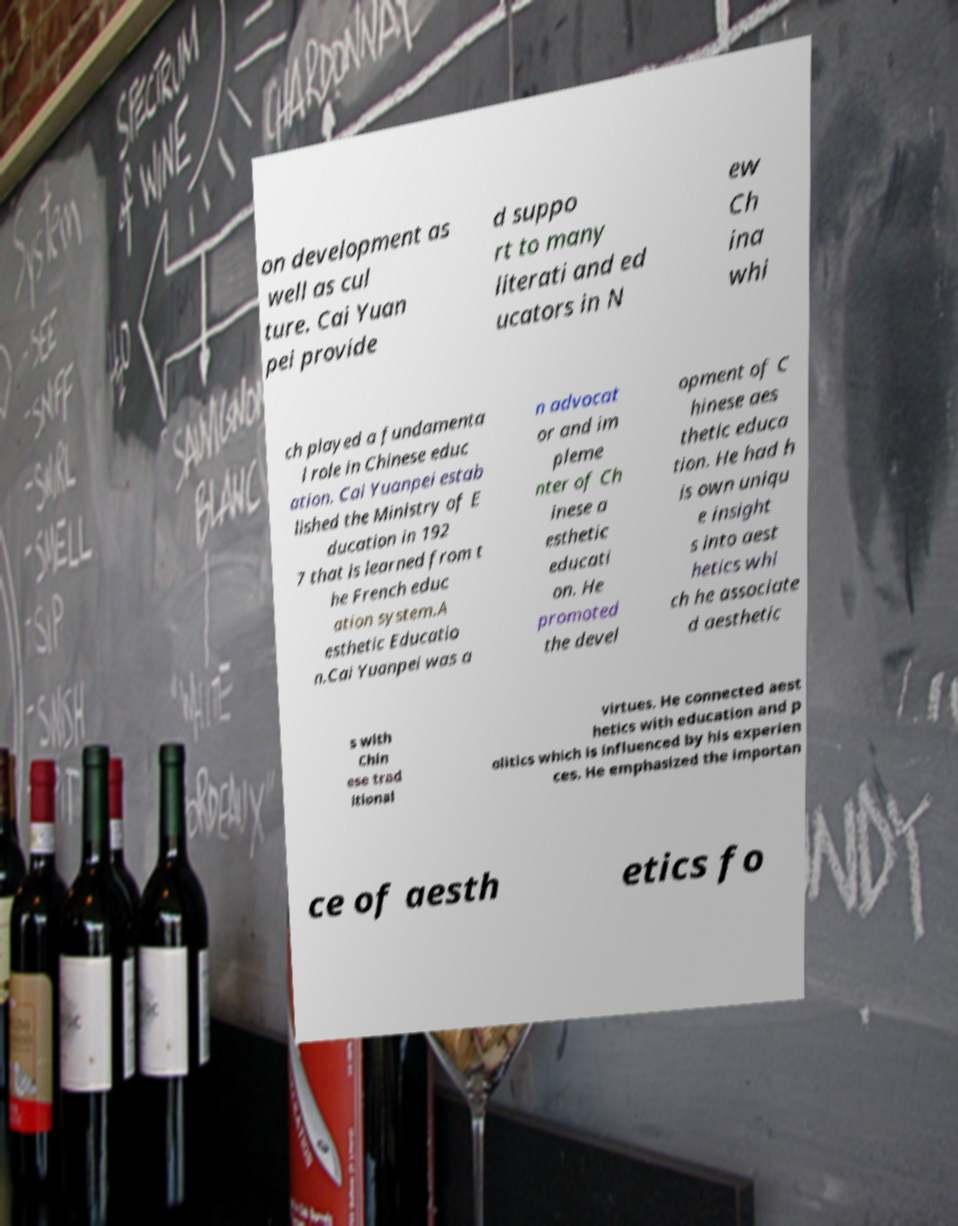Please read and relay the text visible in this image. What does it say? on development as well as cul ture. Cai Yuan pei provide d suppo rt to many literati and ed ucators in N ew Ch ina whi ch played a fundamenta l role in Chinese educ ation. Cai Yuanpei estab lished the Ministry of E ducation in 192 7 that is learned from t he French educ ation system.A esthetic Educatio n.Cai Yuanpei was a n advocat or and im pleme nter of Ch inese a esthetic educati on. He promoted the devel opment of C hinese aes thetic educa tion. He had h is own uniqu e insight s into aest hetics whi ch he associate d aesthetic s with Chin ese trad itional virtues. He connected aest hetics with education and p olitics which is influenced by his experien ces. He emphasized the importan ce of aesth etics fo 